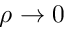<formula> <loc_0><loc_0><loc_500><loc_500>\rho \to 0</formula> 